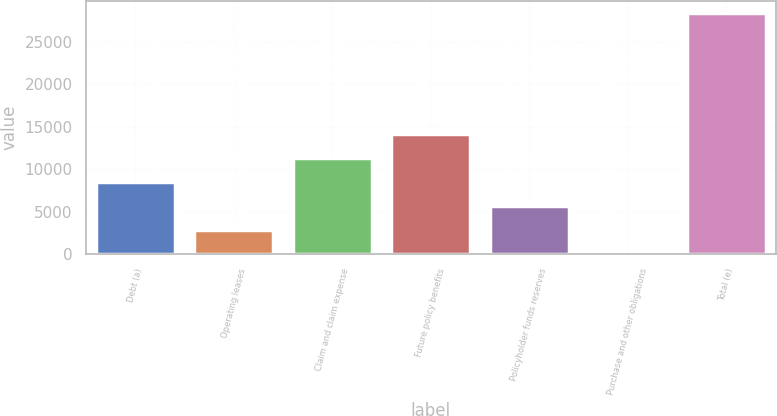Convert chart to OTSL. <chart><loc_0><loc_0><loc_500><loc_500><bar_chart><fcel>Debt (a)<fcel>Operating leases<fcel>Claim and claim expense<fcel>Future policy benefits<fcel>Policyholder funds reserves<fcel>Purchase and other obligations<fcel>Total (e)<nl><fcel>8527.4<fcel>2851.8<fcel>11365.2<fcel>14203<fcel>5689.6<fcel>14<fcel>28392<nl></chart> 